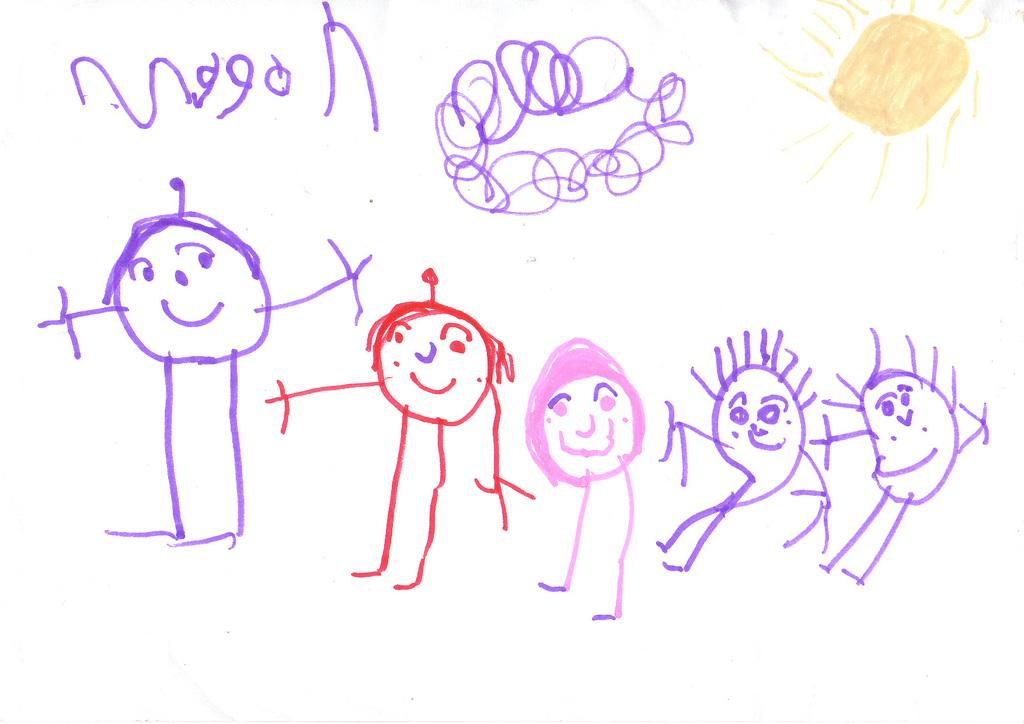What can be seen on the white surface in the image? There are sketches of persons and other objects on the white surface. What is the color of the background in the image? The background is white in color. Can you tell me how many goats are present in the image? There are no goats present in the image; it only features sketches of persons and other objects on a white surface. What type of material is the yard made of in the image? There is no yard present in the image; it only features sketches on a white surface. 